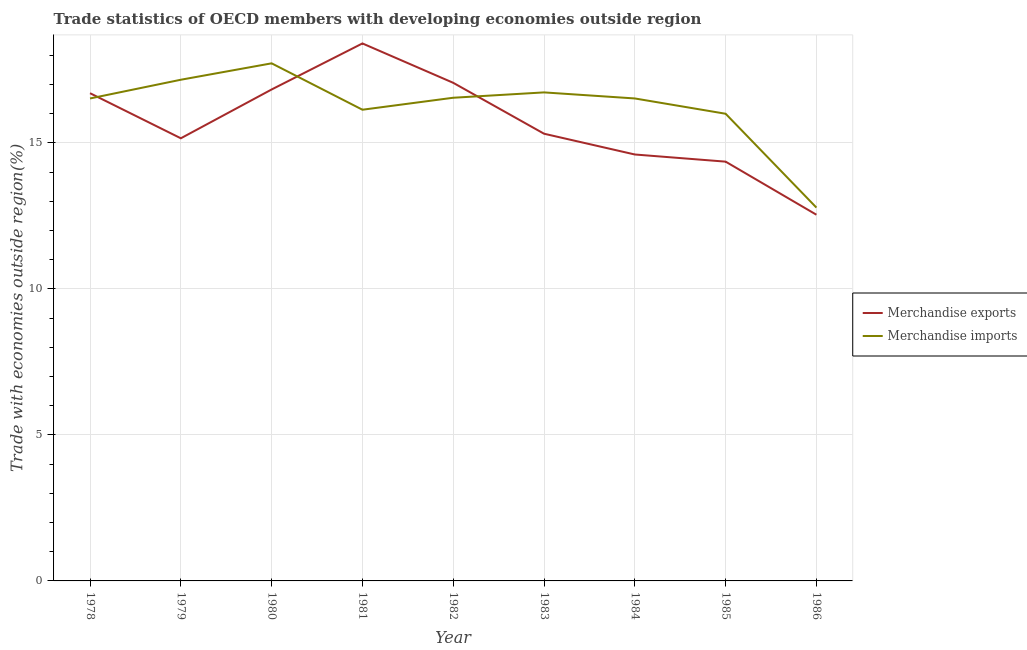Does the line corresponding to merchandise imports intersect with the line corresponding to merchandise exports?
Offer a terse response. Yes. Is the number of lines equal to the number of legend labels?
Your answer should be compact. Yes. What is the merchandise imports in 1983?
Your answer should be very brief. 16.73. Across all years, what is the maximum merchandise imports?
Ensure brevity in your answer.  17.72. Across all years, what is the minimum merchandise exports?
Ensure brevity in your answer.  12.54. In which year was the merchandise imports minimum?
Ensure brevity in your answer.  1986. What is the total merchandise exports in the graph?
Your answer should be very brief. 140.96. What is the difference between the merchandise imports in 1982 and that in 1986?
Make the answer very short. 3.76. What is the difference between the merchandise exports in 1982 and the merchandise imports in 1981?
Your response must be concise. 0.92. What is the average merchandise exports per year?
Provide a succinct answer. 15.66. In the year 1981, what is the difference between the merchandise exports and merchandise imports?
Your response must be concise. 2.27. In how many years, is the merchandise exports greater than 2 %?
Your response must be concise. 9. What is the ratio of the merchandise exports in 1979 to that in 1980?
Make the answer very short. 0.9. Is the difference between the merchandise exports in 1980 and 1983 greater than the difference between the merchandise imports in 1980 and 1983?
Your answer should be compact. Yes. What is the difference between the highest and the second highest merchandise exports?
Your answer should be compact. 1.35. What is the difference between the highest and the lowest merchandise exports?
Your answer should be very brief. 5.87. In how many years, is the merchandise exports greater than the average merchandise exports taken over all years?
Your answer should be very brief. 4. Is the merchandise exports strictly greater than the merchandise imports over the years?
Your answer should be very brief. No. Is the merchandise imports strictly less than the merchandise exports over the years?
Your answer should be compact. No. How many lines are there?
Ensure brevity in your answer.  2. What is the difference between two consecutive major ticks on the Y-axis?
Offer a terse response. 5. Are the values on the major ticks of Y-axis written in scientific E-notation?
Ensure brevity in your answer.  No. Does the graph contain any zero values?
Make the answer very short. No. Where does the legend appear in the graph?
Your answer should be very brief. Center right. How many legend labels are there?
Make the answer very short. 2. How are the legend labels stacked?
Your answer should be compact. Vertical. What is the title of the graph?
Your answer should be compact. Trade statistics of OECD members with developing economies outside region. Does "Revenue" appear as one of the legend labels in the graph?
Provide a short and direct response. No. What is the label or title of the X-axis?
Make the answer very short. Year. What is the label or title of the Y-axis?
Make the answer very short. Trade with economies outside region(%). What is the Trade with economies outside region(%) in Merchandise exports in 1978?
Offer a very short reply. 16.7. What is the Trade with economies outside region(%) in Merchandise imports in 1978?
Your answer should be compact. 16.52. What is the Trade with economies outside region(%) in Merchandise exports in 1979?
Offer a terse response. 15.16. What is the Trade with economies outside region(%) in Merchandise imports in 1979?
Your answer should be compact. 17.16. What is the Trade with economies outside region(%) of Merchandise exports in 1980?
Ensure brevity in your answer.  16.83. What is the Trade with economies outside region(%) in Merchandise imports in 1980?
Your answer should be very brief. 17.72. What is the Trade with economies outside region(%) of Merchandise exports in 1981?
Give a very brief answer. 18.41. What is the Trade with economies outside region(%) of Merchandise imports in 1981?
Give a very brief answer. 16.14. What is the Trade with economies outside region(%) of Merchandise exports in 1982?
Keep it short and to the point. 17.06. What is the Trade with economies outside region(%) of Merchandise imports in 1982?
Provide a succinct answer. 16.55. What is the Trade with economies outside region(%) of Merchandise exports in 1983?
Offer a very short reply. 15.31. What is the Trade with economies outside region(%) of Merchandise imports in 1983?
Provide a short and direct response. 16.73. What is the Trade with economies outside region(%) of Merchandise exports in 1984?
Provide a short and direct response. 14.6. What is the Trade with economies outside region(%) in Merchandise imports in 1984?
Your response must be concise. 16.52. What is the Trade with economies outside region(%) in Merchandise exports in 1985?
Your answer should be compact. 14.36. What is the Trade with economies outside region(%) in Merchandise imports in 1985?
Keep it short and to the point. 16. What is the Trade with economies outside region(%) in Merchandise exports in 1986?
Your answer should be compact. 12.54. What is the Trade with economies outside region(%) of Merchandise imports in 1986?
Make the answer very short. 12.78. Across all years, what is the maximum Trade with economies outside region(%) of Merchandise exports?
Ensure brevity in your answer.  18.41. Across all years, what is the maximum Trade with economies outside region(%) of Merchandise imports?
Provide a succinct answer. 17.72. Across all years, what is the minimum Trade with economies outside region(%) of Merchandise exports?
Keep it short and to the point. 12.54. Across all years, what is the minimum Trade with economies outside region(%) of Merchandise imports?
Give a very brief answer. 12.78. What is the total Trade with economies outside region(%) of Merchandise exports in the graph?
Keep it short and to the point. 140.96. What is the total Trade with economies outside region(%) of Merchandise imports in the graph?
Make the answer very short. 146.12. What is the difference between the Trade with economies outside region(%) of Merchandise exports in 1978 and that in 1979?
Your answer should be compact. 1.54. What is the difference between the Trade with economies outside region(%) of Merchandise imports in 1978 and that in 1979?
Give a very brief answer. -0.64. What is the difference between the Trade with economies outside region(%) in Merchandise exports in 1978 and that in 1980?
Offer a very short reply. -0.13. What is the difference between the Trade with economies outside region(%) in Merchandise imports in 1978 and that in 1980?
Your response must be concise. -1.2. What is the difference between the Trade with economies outside region(%) of Merchandise exports in 1978 and that in 1981?
Your response must be concise. -1.7. What is the difference between the Trade with economies outside region(%) of Merchandise imports in 1978 and that in 1981?
Offer a terse response. 0.39. What is the difference between the Trade with economies outside region(%) of Merchandise exports in 1978 and that in 1982?
Your answer should be very brief. -0.36. What is the difference between the Trade with economies outside region(%) in Merchandise imports in 1978 and that in 1982?
Ensure brevity in your answer.  -0.02. What is the difference between the Trade with economies outside region(%) in Merchandise exports in 1978 and that in 1983?
Your answer should be compact. 1.39. What is the difference between the Trade with economies outside region(%) in Merchandise imports in 1978 and that in 1983?
Ensure brevity in your answer.  -0.21. What is the difference between the Trade with economies outside region(%) in Merchandise exports in 1978 and that in 1984?
Your response must be concise. 2.1. What is the difference between the Trade with economies outside region(%) of Merchandise imports in 1978 and that in 1984?
Keep it short and to the point. -0. What is the difference between the Trade with economies outside region(%) in Merchandise exports in 1978 and that in 1985?
Give a very brief answer. 2.34. What is the difference between the Trade with economies outside region(%) of Merchandise imports in 1978 and that in 1985?
Keep it short and to the point. 0.52. What is the difference between the Trade with economies outside region(%) in Merchandise exports in 1978 and that in 1986?
Your answer should be very brief. 4.16. What is the difference between the Trade with economies outside region(%) of Merchandise imports in 1978 and that in 1986?
Your response must be concise. 3.74. What is the difference between the Trade with economies outside region(%) of Merchandise exports in 1979 and that in 1980?
Offer a very short reply. -1.67. What is the difference between the Trade with economies outside region(%) in Merchandise imports in 1979 and that in 1980?
Offer a terse response. -0.56. What is the difference between the Trade with economies outside region(%) of Merchandise exports in 1979 and that in 1981?
Your answer should be compact. -3.25. What is the difference between the Trade with economies outside region(%) in Merchandise imports in 1979 and that in 1981?
Ensure brevity in your answer.  1.03. What is the difference between the Trade with economies outside region(%) of Merchandise exports in 1979 and that in 1982?
Ensure brevity in your answer.  -1.9. What is the difference between the Trade with economies outside region(%) of Merchandise imports in 1979 and that in 1982?
Make the answer very short. 0.62. What is the difference between the Trade with economies outside region(%) in Merchandise exports in 1979 and that in 1983?
Ensure brevity in your answer.  -0.16. What is the difference between the Trade with economies outside region(%) in Merchandise imports in 1979 and that in 1983?
Offer a very short reply. 0.43. What is the difference between the Trade with economies outside region(%) of Merchandise exports in 1979 and that in 1984?
Give a very brief answer. 0.55. What is the difference between the Trade with economies outside region(%) in Merchandise imports in 1979 and that in 1984?
Offer a terse response. 0.64. What is the difference between the Trade with economies outside region(%) in Merchandise exports in 1979 and that in 1985?
Your answer should be compact. 0.8. What is the difference between the Trade with economies outside region(%) of Merchandise imports in 1979 and that in 1985?
Your response must be concise. 1.16. What is the difference between the Trade with economies outside region(%) of Merchandise exports in 1979 and that in 1986?
Your answer should be compact. 2.62. What is the difference between the Trade with economies outside region(%) in Merchandise imports in 1979 and that in 1986?
Provide a succinct answer. 4.38. What is the difference between the Trade with economies outside region(%) in Merchandise exports in 1980 and that in 1981?
Offer a terse response. -1.58. What is the difference between the Trade with economies outside region(%) in Merchandise imports in 1980 and that in 1981?
Offer a very short reply. 1.59. What is the difference between the Trade with economies outside region(%) of Merchandise exports in 1980 and that in 1982?
Ensure brevity in your answer.  -0.23. What is the difference between the Trade with economies outside region(%) of Merchandise imports in 1980 and that in 1982?
Offer a terse response. 1.18. What is the difference between the Trade with economies outside region(%) of Merchandise exports in 1980 and that in 1983?
Keep it short and to the point. 1.51. What is the difference between the Trade with economies outside region(%) of Merchandise exports in 1980 and that in 1984?
Ensure brevity in your answer.  2.23. What is the difference between the Trade with economies outside region(%) of Merchandise imports in 1980 and that in 1984?
Your answer should be very brief. 1.2. What is the difference between the Trade with economies outside region(%) of Merchandise exports in 1980 and that in 1985?
Give a very brief answer. 2.47. What is the difference between the Trade with economies outside region(%) in Merchandise imports in 1980 and that in 1985?
Offer a terse response. 1.73. What is the difference between the Trade with economies outside region(%) of Merchandise exports in 1980 and that in 1986?
Provide a succinct answer. 4.29. What is the difference between the Trade with economies outside region(%) of Merchandise imports in 1980 and that in 1986?
Provide a short and direct response. 4.94. What is the difference between the Trade with economies outside region(%) of Merchandise exports in 1981 and that in 1982?
Offer a terse response. 1.35. What is the difference between the Trade with economies outside region(%) of Merchandise imports in 1981 and that in 1982?
Make the answer very short. -0.41. What is the difference between the Trade with economies outside region(%) in Merchandise exports in 1981 and that in 1983?
Give a very brief answer. 3.09. What is the difference between the Trade with economies outside region(%) in Merchandise imports in 1981 and that in 1983?
Make the answer very short. -0.59. What is the difference between the Trade with economies outside region(%) in Merchandise exports in 1981 and that in 1984?
Ensure brevity in your answer.  3.8. What is the difference between the Trade with economies outside region(%) in Merchandise imports in 1981 and that in 1984?
Offer a terse response. -0.39. What is the difference between the Trade with economies outside region(%) of Merchandise exports in 1981 and that in 1985?
Provide a short and direct response. 4.05. What is the difference between the Trade with economies outside region(%) of Merchandise imports in 1981 and that in 1985?
Your response must be concise. 0.14. What is the difference between the Trade with economies outside region(%) in Merchandise exports in 1981 and that in 1986?
Provide a short and direct response. 5.87. What is the difference between the Trade with economies outside region(%) in Merchandise imports in 1981 and that in 1986?
Your response must be concise. 3.35. What is the difference between the Trade with economies outside region(%) in Merchandise exports in 1982 and that in 1983?
Offer a terse response. 1.74. What is the difference between the Trade with economies outside region(%) in Merchandise imports in 1982 and that in 1983?
Your answer should be very brief. -0.18. What is the difference between the Trade with economies outside region(%) in Merchandise exports in 1982 and that in 1984?
Provide a succinct answer. 2.45. What is the difference between the Trade with economies outside region(%) of Merchandise imports in 1982 and that in 1984?
Make the answer very short. 0.02. What is the difference between the Trade with economies outside region(%) of Merchandise exports in 1982 and that in 1985?
Keep it short and to the point. 2.7. What is the difference between the Trade with economies outside region(%) in Merchandise imports in 1982 and that in 1985?
Ensure brevity in your answer.  0.55. What is the difference between the Trade with economies outside region(%) in Merchandise exports in 1982 and that in 1986?
Your answer should be compact. 4.52. What is the difference between the Trade with economies outside region(%) of Merchandise imports in 1982 and that in 1986?
Your answer should be compact. 3.76. What is the difference between the Trade with economies outside region(%) in Merchandise exports in 1983 and that in 1984?
Your answer should be very brief. 0.71. What is the difference between the Trade with economies outside region(%) in Merchandise imports in 1983 and that in 1984?
Your answer should be very brief. 0.21. What is the difference between the Trade with economies outside region(%) of Merchandise exports in 1983 and that in 1985?
Keep it short and to the point. 0.96. What is the difference between the Trade with economies outside region(%) of Merchandise imports in 1983 and that in 1985?
Offer a terse response. 0.73. What is the difference between the Trade with economies outside region(%) in Merchandise exports in 1983 and that in 1986?
Provide a succinct answer. 2.77. What is the difference between the Trade with economies outside region(%) of Merchandise imports in 1983 and that in 1986?
Give a very brief answer. 3.94. What is the difference between the Trade with economies outside region(%) of Merchandise exports in 1984 and that in 1985?
Make the answer very short. 0.25. What is the difference between the Trade with economies outside region(%) in Merchandise imports in 1984 and that in 1985?
Your answer should be very brief. 0.52. What is the difference between the Trade with economies outside region(%) of Merchandise exports in 1984 and that in 1986?
Ensure brevity in your answer.  2.06. What is the difference between the Trade with economies outside region(%) in Merchandise imports in 1984 and that in 1986?
Give a very brief answer. 3.74. What is the difference between the Trade with economies outside region(%) in Merchandise exports in 1985 and that in 1986?
Offer a very short reply. 1.82. What is the difference between the Trade with economies outside region(%) in Merchandise imports in 1985 and that in 1986?
Offer a terse response. 3.21. What is the difference between the Trade with economies outside region(%) in Merchandise exports in 1978 and the Trade with economies outside region(%) in Merchandise imports in 1979?
Offer a terse response. -0.46. What is the difference between the Trade with economies outside region(%) in Merchandise exports in 1978 and the Trade with economies outside region(%) in Merchandise imports in 1980?
Make the answer very short. -1.02. What is the difference between the Trade with economies outside region(%) of Merchandise exports in 1978 and the Trade with economies outside region(%) of Merchandise imports in 1981?
Ensure brevity in your answer.  0.57. What is the difference between the Trade with economies outside region(%) in Merchandise exports in 1978 and the Trade with economies outside region(%) in Merchandise imports in 1982?
Your answer should be very brief. 0.16. What is the difference between the Trade with economies outside region(%) in Merchandise exports in 1978 and the Trade with economies outside region(%) in Merchandise imports in 1983?
Your answer should be very brief. -0.03. What is the difference between the Trade with economies outside region(%) of Merchandise exports in 1978 and the Trade with economies outside region(%) of Merchandise imports in 1984?
Make the answer very short. 0.18. What is the difference between the Trade with economies outside region(%) of Merchandise exports in 1978 and the Trade with economies outside region(%) of Merchandise imports in 1985?
Give a very brief answer. 0.7. What is the difference between the Trade with economies outside region(%) of Merchandise exports in 1978 and the Trade with economies outside region(%) of Merchandise imports in 1986?
Keep it short and to the point. 3.92. What is the difference between the Trade with economies outside region(%) in Merchandise exports in 1979 and the Trade with economies outside region(%) in Merchandise imports in 1980?
Provide a short and direct response. -2.57. What is the difference between the Trade with economies outside region(%) of Merchandise exports in 1979 and the Trade with economies outside region(%) of Merchandise imports in 1981?
Provide a succinct answer. -0.98. What is the difference between the Trade with economies outside region(%) in Merchandise exports in 1979 and the Trade with economies outside region(%) in Merchandise imports in 1982?
Your answer should be compact. -1.39. What is the difference between the Trade with economies outside region(%) of Merchandise exports in 1979 and the Trade with economies outside region(%) of Merchandise imports in 1983?
Your answer should be very brief. -1.57. What is the difference between the Trade with economies outside region(%) of Merchandise exports in 1979 and the Trade with economies outside region(%) of Merchandise imports in 1984?
Make the answer very short. -1.36. What is the difference between the Trade with economies outside region(%) of Merchandise exports in 1979 and the Trade with economies outside region(%) of Merchandise imports in 1985?
Keep it short and to the point. -0.84. What is the difference between the Trade with economies outside region(%) in Merchandise exports in 1979 and the Trade with economies outside region(%) in Merchandise imports in 1986?
Offer a terse response. 2.37. What is the difference between the Trade with economies outside region(%) in Merchandise exports in 1980 and the Trade with economies outside region(%) in Merchandise imports in 1981?
Ensure brevity in your answer.  0.69. What is the difference between the Trade with economies outside region(%) in Merchandise exports in 1980 and the Trade with economies outside region(%) in Merchandise imports in 1982?
Your response must be concise. 0.28. What is the difference between the Trade with economies outside region(%) in Merchandise exports in 1980 and the Trade with economies outside region(%) in Merchandise imports in 1983?
Offer a very short reply. 0.1. What is the difference between the Trade with economies outside region(%) in Merchandise exports in 1980 and the Trade with economies outside region(%) in Merchandise imports in 1984?
Ensure brevity in your answer.  0.31. What is the difference between the Trade with economies outside region(%) of Merchandise exports in 1980 and the Trade with economies outside region(%) of Merchandise imports in 1985?
Keep it short and to the point. 0.83. What is the difference between the Trade with economies outside region(%) in Merchandise exports in 1980 and the Trade with economies outside region(%) in Merchandise imports in 1986?
Keep it short and to the point. 4.04. What is the difference between the Trade with economies outside region(%) in Merchandise exports in 1981 and the Trade with economies outside region(%) in Merchandise imports in 1982?
Give a very brief answer. 1.86. What is the difference between the Trade with economies outside region(%) of Merchandise exports in 1981 and the Trade with economies outside region(%) of Merchandise imports in 1983?
Keep it short and to the point. 1.68. What is the difference between the Trade with economies outside region(%) of Merchandise exports in 1981 and the Trade with economies outside region(%) of Merchandise imports in 1984?
Your answer should be compact. 1.88. What is the difference between the Trade with economies outside region(%) of Merchandise exports in 1981 and the Trade with economies outside region(%) of Merchandise imports in 1985?
Provide a succinct answer. 2.41. What is the difference between the Trade with economies outside region(%) in Merchandise exports in 1981 and the Trade with economies outside region(%) in Merchandise imports in 1986?
Keep it short and to the point. 5.62. What is the difference between the Trade with economies outside region(%) in Merchandise exports in 1982 and the Trade with economies outside region(%) in Merchandise imports in 1983?
Ensure brevity in your answer.  0.33. What is the difference between the Trade with economies outside region(%) in Merchandise exports in 1982 and the Trade with economies outside region(%) in Merchandise imports in 1984?
Provide a succinct answer. 0.54. What is the difference between the Trade with economies outside region(%) in Merchandise exports in 1982 and the Trade with economies outside region(%) in Merchandise imports in 1985?
Give a very brief answer. 1.06. What is the difference between the Trade with economies outside region(%) in Merchandise exports in 1982 and the Trade with economies outside region(%) in Merchandise imports in 1986?
Offer a very short reply. 4.27. What is the difference between the Trade with economies outside region(%) in Merchandise exports in 1983 and the Trade with economies outside region(%) in Merchandise imports in 1984?
Offer a very short reply. -1.21. What is the difference between the Trade with economies outside region(%) in Merchandise exports in 1983 and the Trade with economies outside region(%) in Merchandise imports in 1985?
Offer a very short reply. -0.68. What is the difference between the Trade with economies outside region(%) in Merchandise exports in 1983 and the Trade with economies outside region(%) in Merchandise imports in 1986?
Your response must be concise. 2.53. What is the difference between the Trade with economies outside region(%) in Merchandise exports in 1984 and the Trade with economies outside region(%) in Merchandise imports in 1985?
Your answer should be very brief. -1.4. What is the difference between the Trade with economies outside region(%) of Merchandise exports in 1984 and the Trade with economies outside region(%) of Merchandise imports in 1986?
Keep it short and to the point. 1.82. What is the difference between the Trade with economies outside region(%) in Merchandise exports in 1985 and the Trade with economies outside region(%) in Merchandise imports in 1986?
Provide a short and direct response. 1.57. What is the average Trade with economies outside region(%) in Merchandise exports per year?
Make the answer very short. 15.66. What is the average Trade with economies outside region(%) of Merchandise imports per year?
Give a very brief answer. 16.24. In the year 1978, what is the difference between the Trade with economies outside region(%) of Merchandise exports and Trade with economies outside region(%) of Merchandise imports?
Give a very brief answer. 0.18. In the year 1979, what is the difference between the Trade with economies outside region(%) of Merchandise exports and Trade with economies outside region(%) of Merchandise imports?
Keep it short and to the point. -2. In the year 1980, what is the difference between the Trade with economies outside region(%) of Merchandise exports and Trade with economies outside region(%) of Merchandise imports?
Your answer should be very brief. -0.9. In the year 1981, what is the difference between the Trade with economies outside region(%) of Merchandise exports and Trade with economies outside region(%) of Merchandise imports?
Your answer should be compact. 2.27. In the year 1982, what is the difference between the Trade with economies outside region(%) in Merchandise exports and Trade with economies outside region(%) in Merchandise imports?
Provide a short and direct response. 0.51. In the year 1983, what is the difference between the Trade with economies outside region(%) of Merchandise exports and Trade with economies outside region(%) of Merchandise imports?
Give a very brief answer. -1.41. In the year 1984, what is the difference between the Trade with economies outside region(%) of Merchandise exports and Trade with economies outside region(%) of Merchandise imports?
Provide a succinct answer. -1.92. In the year 1985, what is the difference between the Trade with economies outside region(%) in Merchandise exports and Trade with economies outside region(%) in Merchandise imports?
Your answer should be very brief. -1.64. In the year 1986, what is the difference between the Trade with economies outside region(%) in Merchandise exports and Trade with economies outside region(%) in Merchandise imports?
Offer a very short reply. -0.24. What is the ratio of the Trade with economies outside region(%) of Merchandise exports in 1978 to that in 1979?
Your answer should be compact. 1.1. What is the ratio of the Trade with economies outside region(%) in Merchandise imports in 1978 to that in 1979?
Offer a very short reply. 0.96. What is the ratio of the Trade with economies outside region(%) in Merchandise imports in 1978 to that in 1980?
Offer a terse response. 0.93. What is the ratio of the Trade with economies outside region(%) in Merchandise exports in 1978 to that in 1981?
Ensure brevity in your answer.  0.91. What is the ratio of the Trade with economies outside region(%) in Merchandise imports in 1978 to that in 1981?
Provide a succinct answer. 1.02. What is the ratio of the Trade with economies outside region(%) in Merchandise exports in 1978 to that in 1982?
Your response must be concise. 0.98. What is the ratio of the Trade with economies outside region(%) of Merchandise imports in 1978 to that in 1982?
Make the answer very short. 1. What is the ratio of the Trade with economies outside region(%) of Merchandise exports in 1978 to that in 1983?
Provide a short and direct response. 1.09. What is the ratio of the Trade with economies outside region(%) of Merchandise imports in 1978 to that in 1983?
Offer a very short reply. 0.99. What is the ratio of the Trade with economies outside region(%) of Merchandise exports in 1978 to that in 1984?
Your response must be concise. 1.14. What is the ratio of the Trade with economies outside region(%) in Merchandise exports in 1978 to that in 1985?
Keep it short and to the point. 1.16. What is the ratio of the Trade with economies outside region(%) in Merchandise imports in 1978 to that in 1985?
Provide a succinct answer. 1.03. What is the ratio of the Trade with economies outside region(%) of Merchandise exports in 1978 to that in 1986?
Your answer should be very brief. 1.33. What is the ratio of the Trade with economies outside region(%) of Merchandise imports in 1978 to that in 1986?
Give a very brief answer. 1.29. What is the ratio of the Trade with economies outside region(%) in Merchandise exports in 1979 to that in 1980?
Provide a succinct answer. 0.9. What is the ratio of the Trade with economies outside region(%) in Merchandise imports in 1979 to that in 1980?
Provide a succinct answer. 0.97. What is the ratio of the Trade with economies outside region(%) of Merchandise exports in 1979 to that in 1981?
Keep it short and to the point. 0.82. What is the ratio of the Trade with economies outside region(%) of Merchandise imports in 1979 to that in 1981?
Give a very brief answer. 1.06. What is the ratio of the Trade with economies outside region(%) in Merchandise exports in 1979 to that in 1982?
Provide a succinct answer. 0.89. What is the ratio of the Trade with economies outside region(%) of Merchandise imports in 1979 to that in 1982?
Ensure brevity in your answer.  1.04. What is the ratio of the Trade with economies outside region(%) in Merchandise imports in 1979 to that in 1983?
Provide a short and direct response. 1.03. What is the ratio of the Trade with economies outside region(%) of Merchandise exports in 1979 to that in 1984?
Ensure brevity in your answer.  1.04. What is the ratio of the Trade with economies outside region(%) in Merchandise imports in 1979 to that in 1984?
Provide a succinct answer. 1.04. What is the ratio of the Trade with economies outside region(%) in Merchandise exports in 1979 to that in 1985?
Ensure brevity in your answer.  1.06. What is the ratio of the Trade with economies outside region(%) in Merchandise imports in 1979 to that in 1985?
Your response must be concise. 1.07. What is the ratio of the Trade with economies outside region(%) of Merchandise exports in 1979 to that in 1986?
Your answer should be compact. 1.21. What is the ratio of the Trade with economies outside region(%) of Merchandise imports in 1979 to that in 1986?
Ensure brevity in your answer.  1.34. What is the ratio of the Trade with economies outside region(%) in Merchandise exports in 1980 to that in 1981?
Offer a very short reply. 0.91. What is the ratio of the Trade with economies outside region(%) in Merchandise imports in 1980 to that in 1981?
Offer a very short reply. 1.1. What is the ratio of the Trade with economies outside region(%) in Merchandise exports in 1980 to that in 1982?
Keep it short and to the point. 0.99. What is the ratio of the Trade with economies outside region(%) of Merchandise imports in 1980 to that in 1982?
Provide a succinct answer. 1.07. What is the ratio of the Trade with economies outside region(%) in Merchandise exports in 1980 to that in 1983?
Your answer should be compact. 1.1. What is the ratio of the Trade with economies outside region(%) of Merchandise imports in 1980 to that in 1983?
Provide a succinct answer. 1.06. What is the ratio of the Trade with economies outside region(%) in Merchandise exports in 1980 to that in 1984?
Provide a short and direct response. 1.15. What is the ratio of the Trade with economies outside region(%) in Merchandise imports in 1980 to that in 1984?
Your answer should be very brief. 1.07. What is the ratio of the Trade with economies outside region(%) of Merchandise exports in 1980 to that in 1985?
Provide a short and direct response. 1.17. What is the ratio of the Trade with economies outside region(%) in Merchandise imports in 1980 to that in 1985?
Give a very brief answer. 1.11. What is the ratio of the Trade with economies outside region(%) of Merchandise exports in 1980 to that in 1986?
Your response must be concise. 1.34. What is the ratio of the Trade with economies outside region(%) in Merchandise imports in 1980 to that in 1986?
Make the answer very short. 1.39. What is the ratio of the Trade with economies outside region(%) in Merchandise exports in 1981 to that in 1982?
Your answer should be compact. 1.08. What is the ratio of the Trade with economies outside region(%) of Merchandise imports in 1981 to that in 1982?
Keep it short and to the point. 0.98. What is the ratio of the Trade with economies outside region(%) of Merchandise exports in 1981 to that in 1983?
Provide a succinct answer. 1.2. What is the ratio of the Trade with economies outside region(%) in Merchandise imports in 1981 to that in 1983?
Keep it short and to the point. 0.96. What is the ratio of the Trade with economies outside region(%) in Merchandise exports in 1981 to that in 1984?
Your answer should be compact. 1.26. What is the ratio of the Trade with economies outside region(%) in Merchandise imports in 1981 to that in 1984?
Provide a short and direct response. 0.98. What is the ratio of the Trade with economies outside region(%) in Merchandise exports in 1981 to that in 1985?
Provide a succinct answer. 1.28. What is the ratio of the Trade with economies outside region(%) of Merchandise imports in 1981 to that in 1985?
Provide a succinct answer. 1.01. What is the ratio of the Trade with economies outside region(%) of Merchandise exports in 1981 to that in 1986?
Provide a succinct answer. 1.47. What is the ratio of the Trade with economies outside region(%) of Merchandise imports in 1981 to that in 1986?
Provide a succinct answer. 1.26. What is the ratio of the Trade with economies outside region(%) in Merchandise exports in 1982 to that in 1983?
Your answer should be compact. 1.11. What is the ratio of the Trade with economies outside region(%) of Merchandise imports in 1982 to that in 1983?
Give a very brief answer. 0.99. What is the ratio of the Trade with economies outside region(%) of Merchandise exports in 1982 to that in 1984?
Offer a terse response. 1.17. What is the ratio of the Trade with economies outside region(%) of Merchandise exports in 1982 to that in 1985?
Your answer should be compact. 1.19. What is the ratio of the Trade with economies outside region(%) in Merchandise imports in 1982 to that in 1985?
Your response must be concise. 1.03. What is the ratio of the Trade with economies outside region(%) of Merchandise exports in 1982 to that in 1986?
Provide a short and direct response. 1.36. What is the ratio of the Trade with economies outside region(%) of Merchandise imports in 1982 to that in 1986?
Give a very brief answer. 1.29. What is the ratio of the Trade with economies outside region(%) in Merchandise exports in 1983 to that in 1984?
Offer a terse response. 1.05. What is the ratio of the Trade with economies outside region(%) in Merchandise imports in 1983 to that in 1984?
Give a very brief answer. 1.01. What is the ratio of the Trade with economies outside region(%) in Merchandise exports in 1983 to that in 1985?
Provide a succinct answer. 1.07. What is the ratio of the Trade with economies outside region(%) of Merchandise imports in 1983 to that in 1985?
Offer a very short reply. 1.05. What is the ratio of the Trade with economies outside region(%) in Merchandise exports in 1983 to that in 1986?
Your answer should be very brief. 1.22. What is the ratio of the Trade with economies outside region(%) of Merchandise imports in 1983 to that in 1986?
Keep it short and to the point. 1.31. What is the ratio of the Trade with economies outside region(%) of Merchandise exports in 1984 to that in 1985?
Ensure brevity in your answer.  1.02. What is the ratio of the Trade with economies outside region(%) in Merchandise imports in 1984 to that in 1985?
Give a very brief answer. 1.03. What is the ratio of the Trade with economies outside region(%) of Merchandise exports in 1984 to that in 1986?
Give a very brief answer. 1.16. What is the ratio of the Trade with economies outside region(%) of Merchandise imports in 1984 to that in 1986?
Your answer should be compact. 1.29. What is the ratio of the Trade with economies outside region(%) of Merchandise exports in 1985 to that in 1986?
Your response must be concise. 1.14. What is the ratio of the Trade with economies outside region(%) of Merchandise imports in 1985 to that in 1986?
Offer a very short reply. 1.25. What is the difference between the highest and the second highest Trade with economies outside region(%) of Merchandise exports?
Offer a terse response. 1.35. What is the difference between the highest and the second highest Trade with economies outside region(%) in Merchandise imports?
Give a very brief answer. 0.56. What is the difference between the highest and the lowest Trade with economies outside region(%) of Merchandise exports?
Your response must be concise. 5.87. What is the difference between the highest and the lowest Trade with economies outside region(%) of Merchandise imports?
Offer a very short reply. 4.94. 